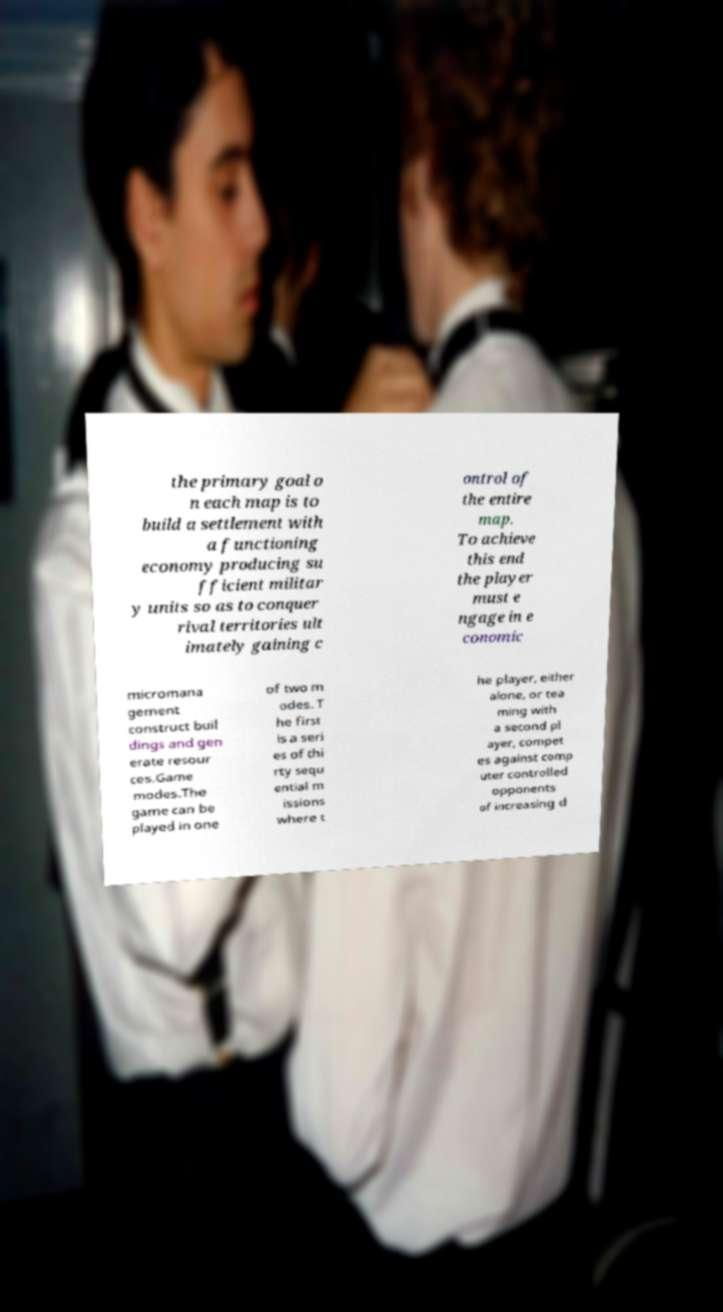Could you assist in decoding the text presented in this image and type it out clearly? the primary goal o n each map is to build a settlement with a functioning economy producing su fficient militar y units so as to conquer rival territories ult imately gaining c ontrol of the entire map. To achieve this end the player must e ngage in e conomic micromana gement construct buil dings and gen erate resour ces.Game modes.The game can be played in one of two m odes. T he first is a seri es of thi rty sequ ential m issions where t he player, either alone, or tea ming with a second pl ayer, compet es against comp uter controlled opponents of increasing d 